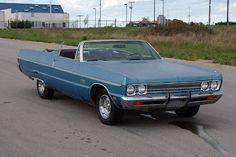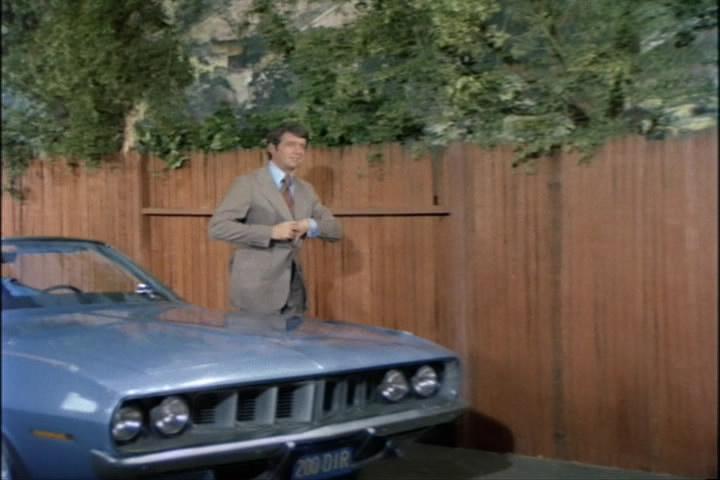The first image is the image on the left, the second image is the image on the right. Given the left and right images, does the statement "There is more than one person in one of the cars." hold true? Answer yes or no. No. The first image is the image on the left, the second image is the image on the right. Assess this claim about the two images: "A man in a brown suit is standing.". Correct or not? Answer yes or no. Yes. 